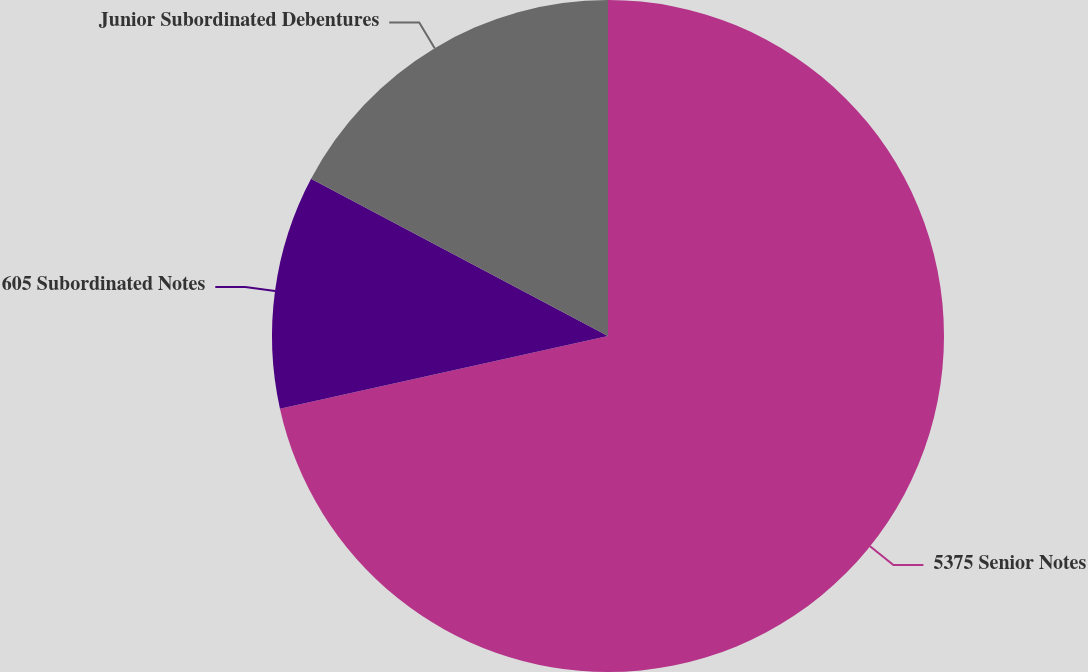Convert chart. <chart><loc_0><loc_0><loc_500><loc_500><pie_chart><fcel>5375 Senior Notes<fcel>605 Subordinated Notes<fcel>Junior Subordinated Debentures<nl><fcel>71.53%<fcel>11.22%<fcel>17.25%<nl></chart> 